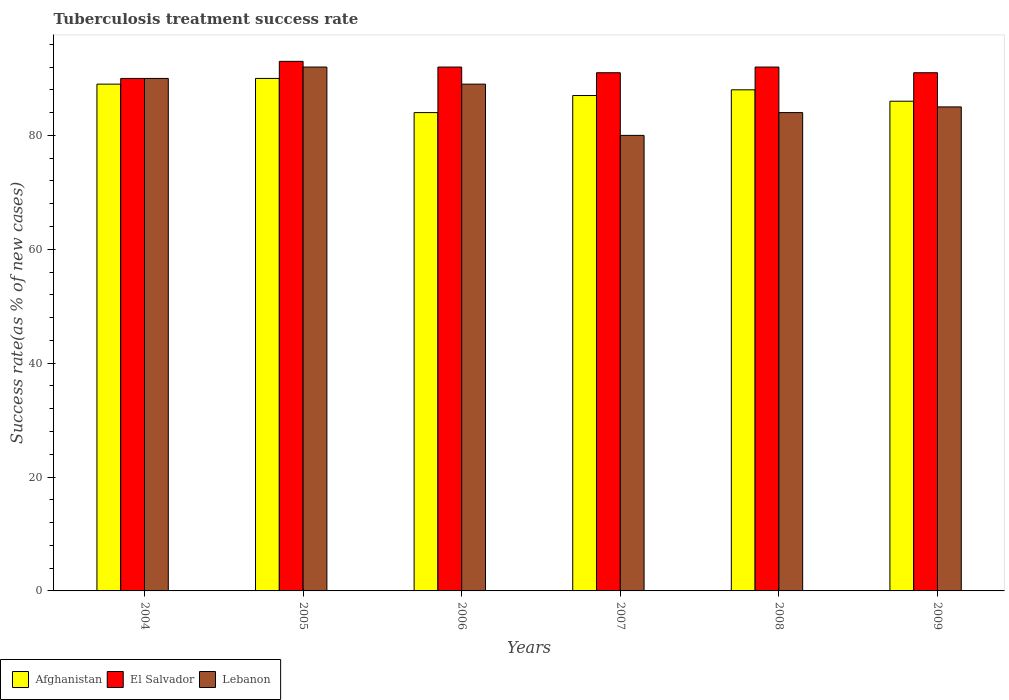How many different coloured bars are there?
Your response must be concise. 3. How many groups of bars are there?
Offer a very short reply. 6. Are the number of bars on each tick of the X-axis equal?
Your answer should be compact. Yes. How many bars are there on the 4th tick from the left?
Offer a terse response. 3. How many bars are there on the 6th tick from the right?
Provide a short and direct response. 3. In how many cases, is the number of bars for a given year not equal to the number of legend labels?
Your answer should be very brief. 0. What is the tuberculosis treatment success rate in Lebanon in 2006?
Your answer should be compact. 89. Across all years, what is the maximum tuberculosis treatment success rate in Lebanon?
Keep it short and to the point. 92. Across all years, what is the minimum tuberculosis treatment success rate in Lebanon?
Offer a terse response. 80. In which year was the tuberculosis treatment success rate in El Salvador minimum?
Your answer should be compact. 2004. What is the total tuberculosis treatment success rate in Afghanistan in the graph?
Provide a succinct answer. 524. What is the difference between the tuberculosis treatment success rate in Lebanon in 2004 and that in 2006?
Ensure brevity in your answer.  1. What is the difference between the tuberculosis treatment success rate in Afghanistan in 2005 and the tuberculosis treatment success rate in Lebanon in 2004?
Give a very brief answer. 0. What is the average tuberculosis treatment success rate in Lebanon per year?
Keep it short and to the point. 86.67. In how many years, is the tuberculosis treatment success rate in Afghanistan greater than 76 %?
Give a very brief answer. 6. What is the ratio of the tuberculosis treatment success rate in El Salvador in 2004 to that in 2006?
Your answer should be compact. 0.98. Is the tuberculosis treatment success rate in Lebanon in 2004 less than that in 2005?
Keep it short and to the point. Yes. What does the 3rd bar from the left in 2009 represents?
Offer a terse response. Lebanon. What does the 3rd bar from the right in 2007 represents?
Your response must be concise. Afghanistan. How many years are there in the graph?
Your answer should be very brief. 6. What is the difference between two consecutive major ticks on the Y-axis?
Offer a very short reply. 20. Does the graph contain any zero values?
Your answer should be compact. No. Does the graph contain grids?
Make the answer very short. No. How many legend labels are there?
Keep it short and to the point. 3. What is the title of the graph?
Keep it short and to the point. Tuberculosis treatment success rate. What is the label or title of the X-axis?
Provide a short and direct response. Years. What is the label or title of the Y-axis?
Your answer should be very brief. Success rate(as % of new cases). What is the Success rate(as % of new cases) of Afghanistan in 2004?
Provide a short and direct response. 89. What is the Success rate(as % of new cases) of Afghanistan in 2005?
Offer a terse response. 90. What is the Success rate(as % of new cases) in El Salvador in 2005?
Give a very brief answer. 93. What is the Success rate(as % of new cases) of Lebanon in 2005?
Ensure brevity in your answer.  92. What is the Success rate(as % of new cases) in El Salvador in 2006?
Your answer should be compact. 92. What is the Success rate(as % of new cases) of Lebanon in 2006?
Your answer should be compact. 89. What is the Success rate(as % of new cases) in Afghanistan in 2007?
Make the answer very short. 87. What is the Success rate(as % of new cases) in El Salvador in 2007?
Make the answer very short. 91. What is the Success rate(as % of new cases) of El Salvador in 2008?
Offer a terse response. 92. What is the Success rate(as % of new cases) in Afghanistan in 2009?
Your answer should be very brief. 86. What is the Success rate(as % of new cases) of El Salvador in 2009?
Offer a terse response. 91. Across all years, what is the maximum Success rate(as % of new cases) of El Salvador?
Make the answer very short. 93. Across all years, what is the maximum Success rate(as % of new cases) of Lebanon?
Offer a very short reply. 92. Across all years, what is the minimum Success rate(as % of new cases) in Afghanistan?
Offer a very short reply. 84. Across all years, what is the minimum Success rate(as % of new cases) in El Salvador?
Your answer should be compact. 90. What is the total Success rate(as % of new cases) in Afghanistan in the graph?
Keep it short and to the point. 524. What is the total Success rate(as % of new cases) in El Salvador in the graph?
Your response must be concise. 549. What is the total Success rate(as % of new cases) of Lebanon in the graph?
Make the answer very short. 520. What is the difference between the Success rate(as % of new cases) in Afghanistan in 2004 and that in 2005?
Ensure brevity in your answer.  -1. What is the difference between the Success rate(as % of new cases) of El Salvador in 2004 and that in 2007?
Give a very brief answer. -1. What is the difference between the Success rate(as % of new cases) in Lebanon in 2004 and that in 2007?
Give a very brief answer. 10. What is the difference between the Success rate(as % of new cases) in El Salvador in 2004 and that in 2008?
Your response must be concise. -2. What is the difference between the Success rate(as % of new cases) of Lebanon in 2004 and that in 2008?
Offer a terse response. 6. What is the difference between the Success rate(as % of new cases) in Afghanistan in 2004 and that in 2009?
Your answer should be compact. 3. What is the difference between the Success rate(as % of new cases) in Lebanon in 2004 and that in 2009?
Offer a terse response. 5. What is the difference between the Success rate(as % of new cases) in Lebanon in 2005 and that in 2006?
Provide a succinct answer. 3. What is the difference between the Success rate(as % of new cases) in El Salvador in 2005 and that in 2007?
Your answer should be compact. 2. What is the difference between the Success rate(as % of new cases) of Afghanistan in 2005 and that in 2009?
Your response must be concise. 4. What is the difference between the Success rate(as % of new cases) of El Salvador in 2005 and that in 2009?
Make the answer very short. 2. What is the difference between the Success rate(as % of new cases) in Afghanistan in 2006 and that in 2007?
Provide a short and direct response. -3. What is the difference between the Success rate(as % of new cases) of Afghanistan in 2006 and that in 2008?
Ensure brevity in your answer.  -4. What is the difference between the Success rate(as % of new cases) of Lebanon in 2006 and that in 2008?
Provide a succinct answer. 5. What is the difference between the Success rate(as % of new cases) of Afghanistan in 2006 and that in 2009?
Provide a succinct answer. -2. What is the difference between the Success rate(as % of new cases) of Lebanon in 2006 and that in 2009?
Provide a succinct answer. 4. What is the difference between the Success rate(as % of new cases) in Afghanistan in 2007 and that in 2009?
Give a very brief answer. 1. What is the difference between the Success rate(as % of new cases) in Lebanon in 2007 and that in 2009?
Provide a short and direct response. -5. What is the difference between the Success rate(as % of new cases) of Lebanon in 2008 and that in 2009?
Keep it short and to the point. -1. What is the difference between the Success rate(as % of new cases) in Afghanistan in 2004 and the Success rate(as % of new cases) in El Salvador in 2005?
Your answer should be very brief. -4. What is the difference between the Success rate(as % of new cases) of El Salvador in 2004 and the Success rate(as % of new cases) of Lebanon in 2005?
Offer a very short reply. -2. What is the difference between the Success rate(as % of new cases) of Afghanistan in 2004 and the Success rate(as % of new cases) of El Salvador in 2006?
Offer a terse response. -3. What is the difference between the Success rate(as % of new cases) in El Salvador in 2004 and the Success rate(as % of new cases) in Lebanon in 2007?
Give a very brief answer. 10. What is the difference between the Success rate(as % of new cases) of Afghanistan in 2004 and the Success rate(as % of new cases) of El Salvador in 2008?
Offer a terse response. -3. What is the difference between the Success rate(as % of new cases) of Afghanistan in 2004 and the Success rate(as % of new cases) of Lebanon in 2008?
Provide a succinct answer. 5. What is the difference between the Success rate(as % of new cases) in El Salvador in 2004 and the Success rate(as % of new cases) in Lebanon in 2008?
Your answer should be very brief. 6. What is the difference between the Success rate(as % of new cases) in Afghanistan in 2004 and the Success rate(as % of new cases) in El Salvador in 2009?
Provide a short and direct response. -2. What is the difference between the Success rate(as % of new cases) in Afghanistan in 2005 and the Success rate(as % of new cases) in El Salvador in 2006?
Your answer should be compact. -2. What is the difference between the Success rate(as % of new cases) in Afghanistan in 2005 and the Success rate(as % of new cases) in Lebanon in 2006?
Ensure brevity in your answer.  1. What is the difference between the Success rate(as % of new cases) of El Salvador in 2005 and the Success rate(as % of new cases) of Lebanon in 2006?
Your response must be concise. 4. What is the difference between the Success rate(as % of new cases) in Afghanistan in 2005 and the Success rate(as % of new cases) in El Salvador in 2007?
Provide a succinct answer. -1. What is the difference between the Success rate(as % of new cases) of Afghanistan in 2005 and the Success rate(as % of new cases) of El Salvador in 2008?
Provide a short and direct response. -2. What is the difference between the Success rate(as % of new cases) of El Salvador in 2005 and the Success rate(as % of new cases) of Lebanon in 2008?
Give a very brief answer. 9. What is the difference between the Success rate(as % of new cases) in El Salvador in 2005 and the Success rate(as % of new cases) in Lebanon in 2009?
Provide a succinct answer. 8. What is the difference between the Success rate(as % of new cases) of Afghanistan in 2006 and the Success rate(as % of new cases) of El Salvador in 2007?
Make the answer very short. -7. What is the difference between the Success rate(as % of new cases) of Afghanistan in 2006 and the Success rate(as % of new cases) of El Salvador in 2009?
Give a very brief answer. -7. What is the difference between the Success rate(as % of new cases) in Afghanistan in 2007 and the Success rate(as % of new cases) in El Salvador in 2008?
Give a very brief answer. -5. What is the difference between the Success rate(as % of new cases) in Afghanistan in 2007 and the Success rate(as % of new cases) in Lebanon in 2008?
Offer a terse response. 3. What is the difference between the Success rate(as % of new cases) of El Salvador in 2007 and the Success rate(as % of new cases) of Lebanon in 2008?
Provide a succinct answer. 7. What is the difference between the Success rate(as % of new cases) in Afghanistan in 2007 and the Success rate(as % of new cases) in El Salvador in 2009?
Offer a terse response. -4. What is the difference between the Success rate(as % of new cases) in Afghanistan in 2008 and the Success rate(as % of new cases) in El Salvador in 2009?
Keep it short and to the point. -3. What is the difference between the Success rate(as % of new cases) of El Salvador in 2008 and the Success rate(as % of new cases) of Lebanon in 2009?
Your answer should be compact. 7. What is the average Success rate(as % of new cases) in Afghanistan per year?
Provide a short and direct response. 87.33. What is the average Success rate(as % of new cases) in El Salvador per year?
Your answer should be very brief. 91.5. What is the average Success rate(as % of new cases) of Lebanon per year?
Keep it short and to the point. 86.67. In the year 2004, what is the difference between the Success rate(as % of new cases) of Afghanistan and Success rate(as % of new cases) of El Salvador?
Your answer should be compact. -1. In the year 2005, what is the difference between the Success rate(as % of new cases) in El Salvador and Success rate(as % of new cases) in Lebanon?
Keep it short and to the point. 1. In the year 2006, what is the difference between the Success rate(as % of new cases) of Afghanistan and Success rate(as % of new cases) of El Salvador?
Keep it short and to the point. -8. In the year 2006, what is the difference between the Success rate(as % of new cases) in El Salvador and Success rate(as % of new cases) in Lebanon?
Your answer should be very brief. 3. In the year 2007, what is the difference between the Success rate(as % of new cases) in Afghanistan and Success rate(as % of new cases) in El Salvador?
Offer a very short reply. -4. In the year 2007, what is the difference between the Success rate(as % of new cases) in Afghanistan and Success rate(as % of new cases) in Lebanon?
Your answer should be compact. 7. In the year 2007, what is the difference between the Success rate(as % of new cases) of El Salvador and Success rate(as % of new cases) of Lebanon?
Provide a succinct answer. 11. In the year 2008, what is the difference between the Success rate(as % of new cases) in Afghanistan and Success rate(as % of new cases) in Lebanon?
Make the answer very short. 4. In the year 2009, what is the difference between the Success rate(as % of new cases) of Afghanistan and Success rate(as % of new cases) of El Salvador?
Keep it short and to the point. -5. In the year 2009, what is the difference between the Success rate(as % of new cases) in Afghanistan and Success rate(as % of new cases) in Lebanon?
Offer a terse response. 1. In the year 2009, what is the difference between the Success rate(as % of new cases) in El Salvador and Success rate(as % of new cases) in Lebanon?
Give a very brief answer. 6. What is the ratio of the Success rate(as % of new cases) of Afghanistan in 2004 to that in 2005?
Keep it short and to the point. 0.99. What is the ratio of the Success rate(as % of new cases) in El Salvador in 2004 to that in 2005?
Give a very brief answer. 0.97. What is the ratio of the Success rate(as % of new cases) of Lebanon in 2004 to that in 2005?
Provide a short and direct response. 0.98. What is the ratio of the Success rate(as % of new cases) of Afghanistan in 2004 to that in 2006?
Keep it short and to the point. 1.06. What is the ratio of the Success rate(as % of new cases) of El Salvador in 2004 to that in 2006?
Provide a short and direct response. 0.98. What is the ratio of the Success rate(as % of new cases) of Lebanon in 2004 to that in 2006?
Give a very brief answer. 1.01. What is the ratio of the Success rate(as % of new cases) in El Salvador in 2004 to that in 2007?
Offer a very short reply. 0.99. What is the ratio of the Success rate(as % of new cases) of Afghanistan in 2004 to that in 2008?
Offer a very short reply. 1.01. What is the ratio of the Success rate(as % of new cases) in El Salvador in 2004 to that in 2008?
Your response must be concise. 0.98. What is the ratio of the Success rate(as % of new cases) of Lebanon in 2004 to that in 2008?
Your response must be concise. 1.07. What is the ratio of the Success rate(as % of new cases) of Afghanistan in 2004 to that in 2009?
Your response must be concise. 1.03. What is the ratio of the Success rate(as % of new cases) in Lebanon in 2004 to that in 2009?
Make the answer very short. 1.06. What is the ratio of the Success rate(as % of new cases) of Afghanistan in 2005 to that in 2006?
Offer a very short reply. 1.07. What is the ratio of the Success rate(as % of new cases) of El Salvador in 2005 to that in 2006?
Offer a very short reply. 1.01. What is the ratio of the Success rate(as % of new cases) in Lebanon in 2005 to that in 2006?
Keep it short and to the point. 1.03. What is the ratio of the Success rate(as % of new cases) in Afghanistan in 2005 to that in 2007?
Ensure brevity in your answer.  1.03. What is the ratio of the Success rate(as % of new cases) of El Salvador in 2005 to that in 2007?
Make the answer very short. 1.02. What is the ratio of the Success rate(as % of new cases) of Lebanon in 2005 to that in 2007?
Offer a very short reply. 1.15. What is the ratio of the Success rate(as % of new cases) of Afghanistan in 2005 to that in 2008?
Your answer should be very brief. 1.02. What is the ratio of the Success rate(as % of new cases) of El Salvador in 2005 to that in 2008?
Offer a terse response. 1.01. What is the ratio of the Success rate(as % of new cases) in Lebanon in 2005 to that in 2008?
Offer a terse response. 1.1. What is the ratio of the Success rate(as % of new cases) of Afghanistan in 2005 to that in 2009?
Keep it short and to the point. 1.05. What is the ratio of the Success rate(as % of new cases) in Lebanon in 2005 to that in 2009?
Provide a succinct answer. 1.08. What is the ratio of the Success rate(as % of new cases) of Afghanistan in 2006 to that in 2007?
Your answer should be compact. 0.97. What is the ratio of the Success rate(as % of new cases) of El Salvador in 2006 to that in 2007?
Ensure brevity in your answer.  1.01. What is the ratio of the Success rate(as % of new cases) in Lebanon in 2006 to that in 2007?
Your answer should be compact. 1.11. What is the ratio of the Success rate(as % of new cases) of Afghanistan in 2006 to that in 2008?
Your answer should be very brief. 0.95. What is the ratio of the Success rate(as % of new cases) of Lebanon in 2006 to that in 2008?
Provide a succinct answer. 1.06. What is the ratio of the Success rate(as % of new cases) of Afghanistan in 2006 to that in 2009?
Ensure brevity in your answer.  0.98. What is the ratio of the Success rate(as % of new cases) in El Salvador in 2006 to that in 2009?
Provide a short and direct response. 1.01. What is the ratio of the Success rate(as % of new cases) of Lebanon in 2006 to that in 2009?
Your response must be concise. 1.05. What is the ratio of the Success rate(as % of new cases) of Afghanistan in 2007 to that in 2008?
Offer a very short reply. 0.99. What is the ratio of the Success rate(as % of new cases) of Afghanistan in 2007 to that in 2009?
Provide a short and direct response. 1.01. What is the ratio of the Success rate(as % of new cases) of El Salvador in 2007 to that in 2009?
Ensure brevity in your answer.  1. What is the ratio of the Success rate(as % of new cases) in Afghanistan in 2008 to that in 2009?
Provide a succinct answer. 1.02. What is the ratio of the Success rate(as % of new cases) of El Salvador in 2008 to that in 2009?
Your response must be concise. 1.01. What is the ratio of the Success rate(as % of new cases) in Lebanon in 2008 to that in 2009?
Ensure brevity in your answer.  0.99. What is the difference between the highest and the second highest Success rate(as % of new cases) in Afghanistan?
Make the answer very short. 1. What is the difference between the highest and the second highest Success rate(as % of new cases) in El Salvador?
Provide a short and direct response. 1. What is the difference between the highest and the lowest Success rate(as % of new cases) of Afghanistan?
Offer a very short reply. 6. 